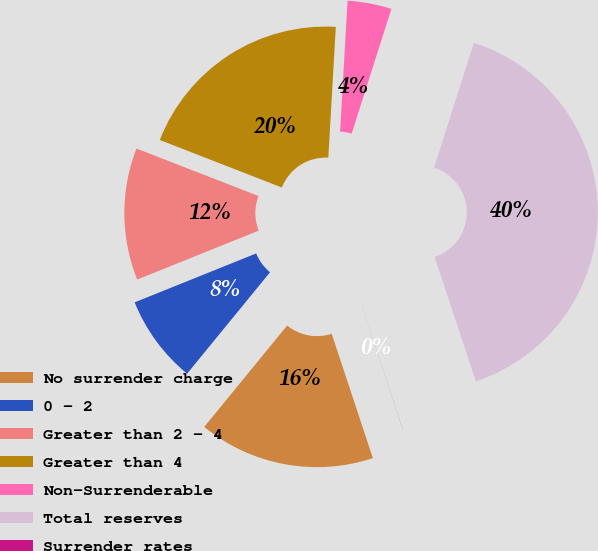Convert chart to OTSL. <chart><loc_0><loc_0><loc_500><loc_500><pie_chart><fcel>No surrender charge<fcel>0 - 2<fcel>Greater than 2 - 4<fcel>Greater than 4<fcel>Non-Surrenderable<fcel>Total reserves<fcel>Surrender rates<nl><fcel>16.0%<fcel>8.0%<fcel>12.0%<fcel>20.0%<fcel>4.0%<fcel>39.99%<fcel>0.01%<nl></chart> 